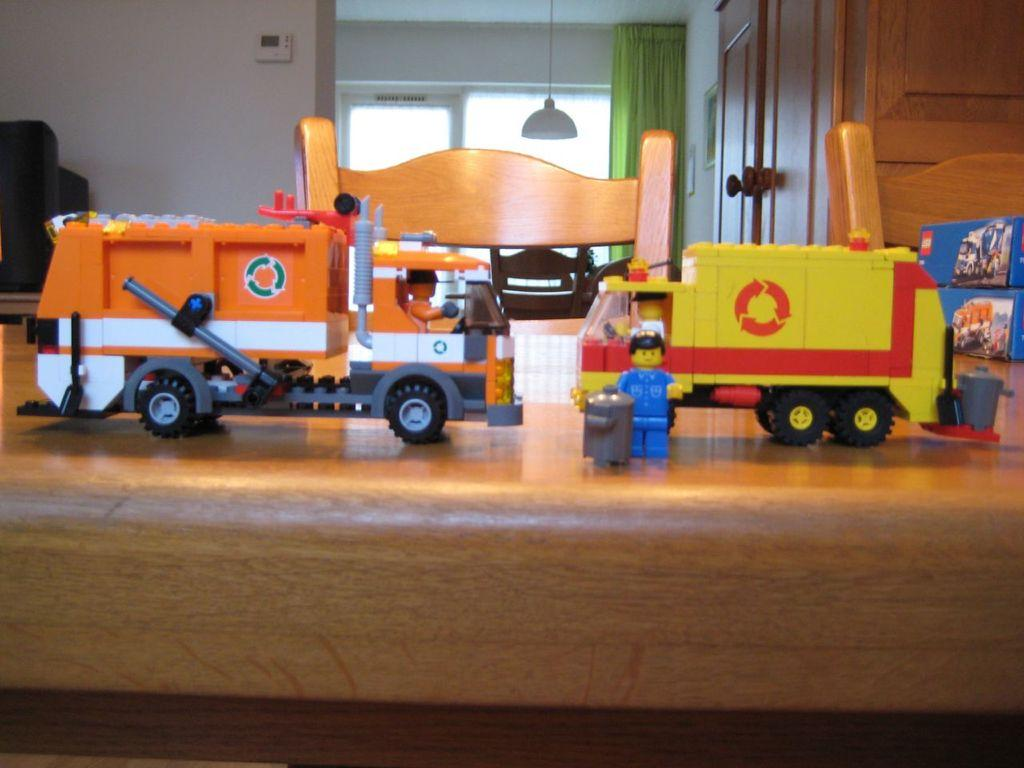What type of furniture is present in the image? There is a table in the image. What object is placed on the table? There is a toy train on the table. Are there any seating options visible in the image? Yes, there are chairs in the image. What can be seen on the walls in the image? There are walls visible in the image. What type of window treatment is present in the image? There are curtains associated with the windows. What type of lighting fixture is hanging from the top in the image? A light is hanging from the top in the image. What type of knowledge can be gained from the mountain in the image? There is no mountain present in the image, so no knowledge can be gained from it. How many clovers are visible on the table in the image? There are no clovers present on the table in the image. 